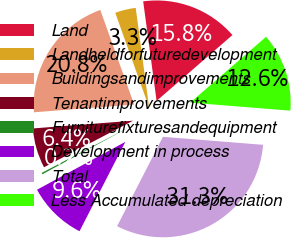<chart> <loc_0><loc_0><loc_500><loc_500><pie_chart><fcel>Land<fcel>Landheldforfuturedevelopment<fcel>Buildingsandimprovements<fcel>Tenantimprovements<fcel>Furniturefixturesandequipment<fcel>Development in process<fcel>Total<fcel>Less Accumulated depreciation<nl><fcel>15.75%<fcel>3.34%<fcel>20.76%<fcel>6.44%<fcel>0.24%<fcel>9.55%<fcel>31.27%<fcel>12.65%<nl></chart> 